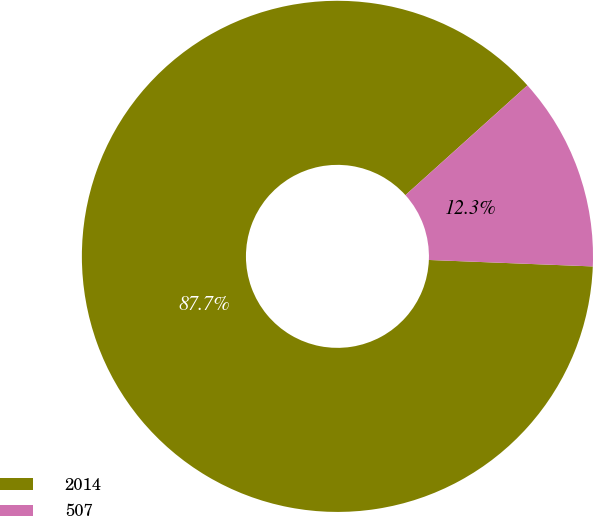Convert chart to OTSL. <chart><loc_0><loc_0><loc_500><loc_500><pie_chart><fcel>2014<fcel>507<nl><fcel>87.71%<fcel>12.29%<nl></chart> 